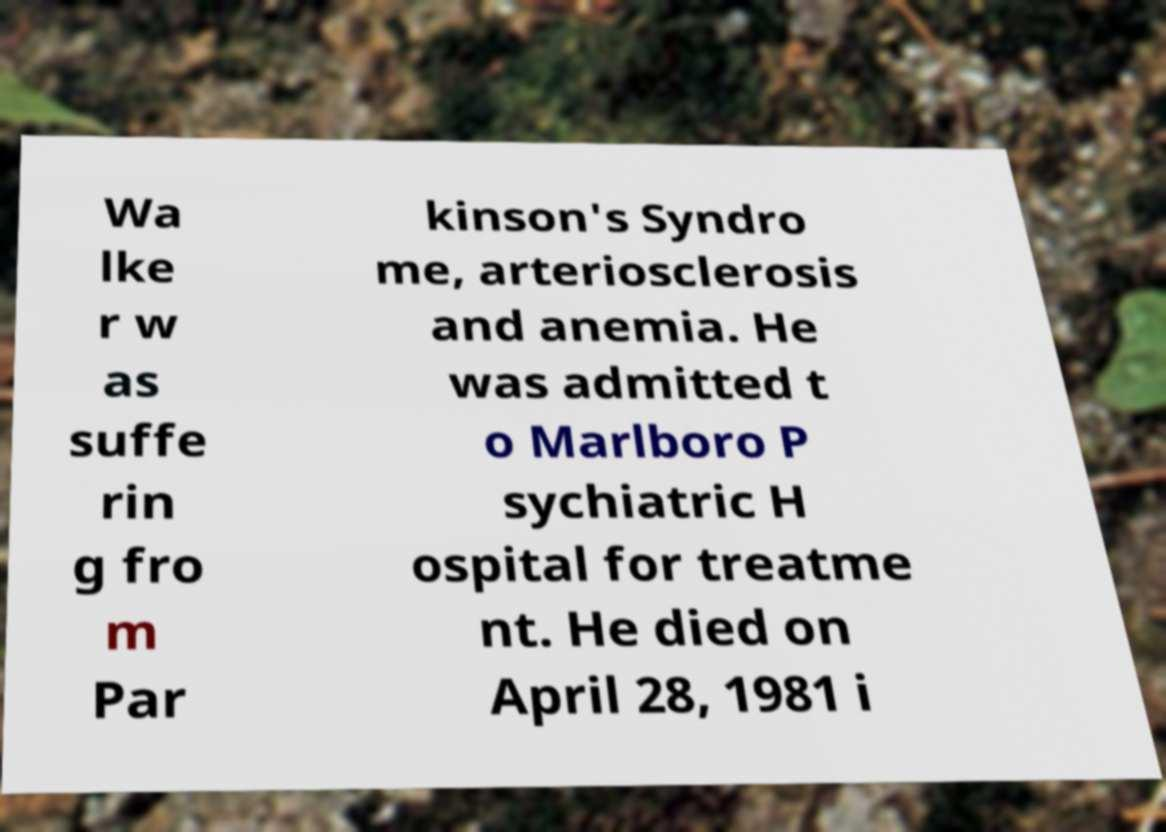There's text embedded in this image that I need extracted. Can you transcribe it verbatim? Wa lke r w as suffe rin g fro m Par kinson's Syndro me, arteriosclerosis and anemia. He was admitted t o Marlboro P sychiatric H ospital for treatme nt. He died on April 28, 1981 i 